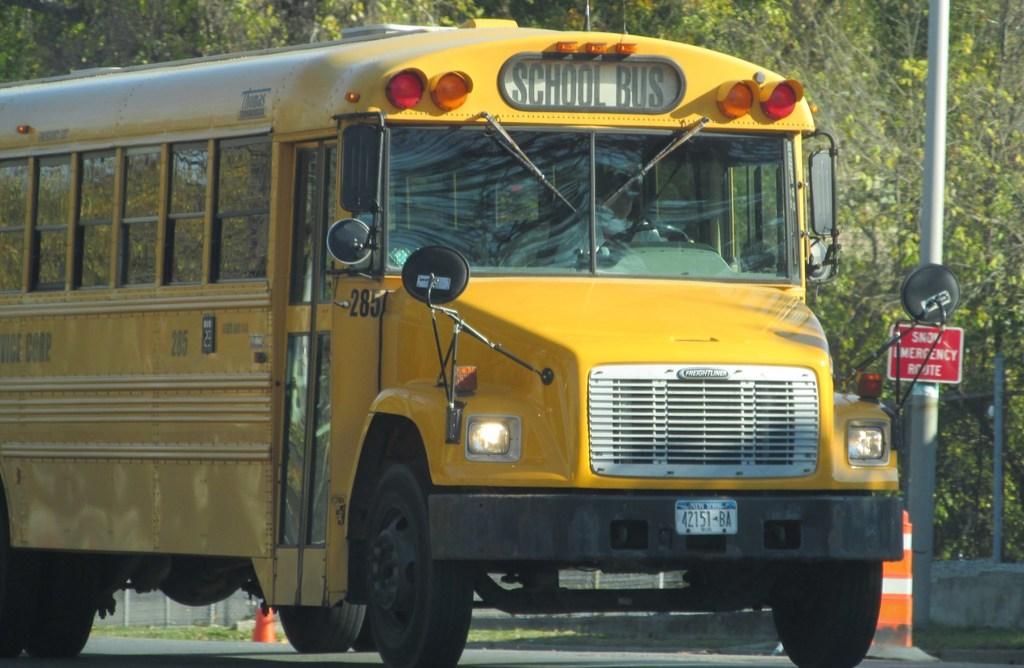What type of b us is this?
Make the answer very short. School bus. Is this vehicle for school?
Your answer should be very brief. Yes. 